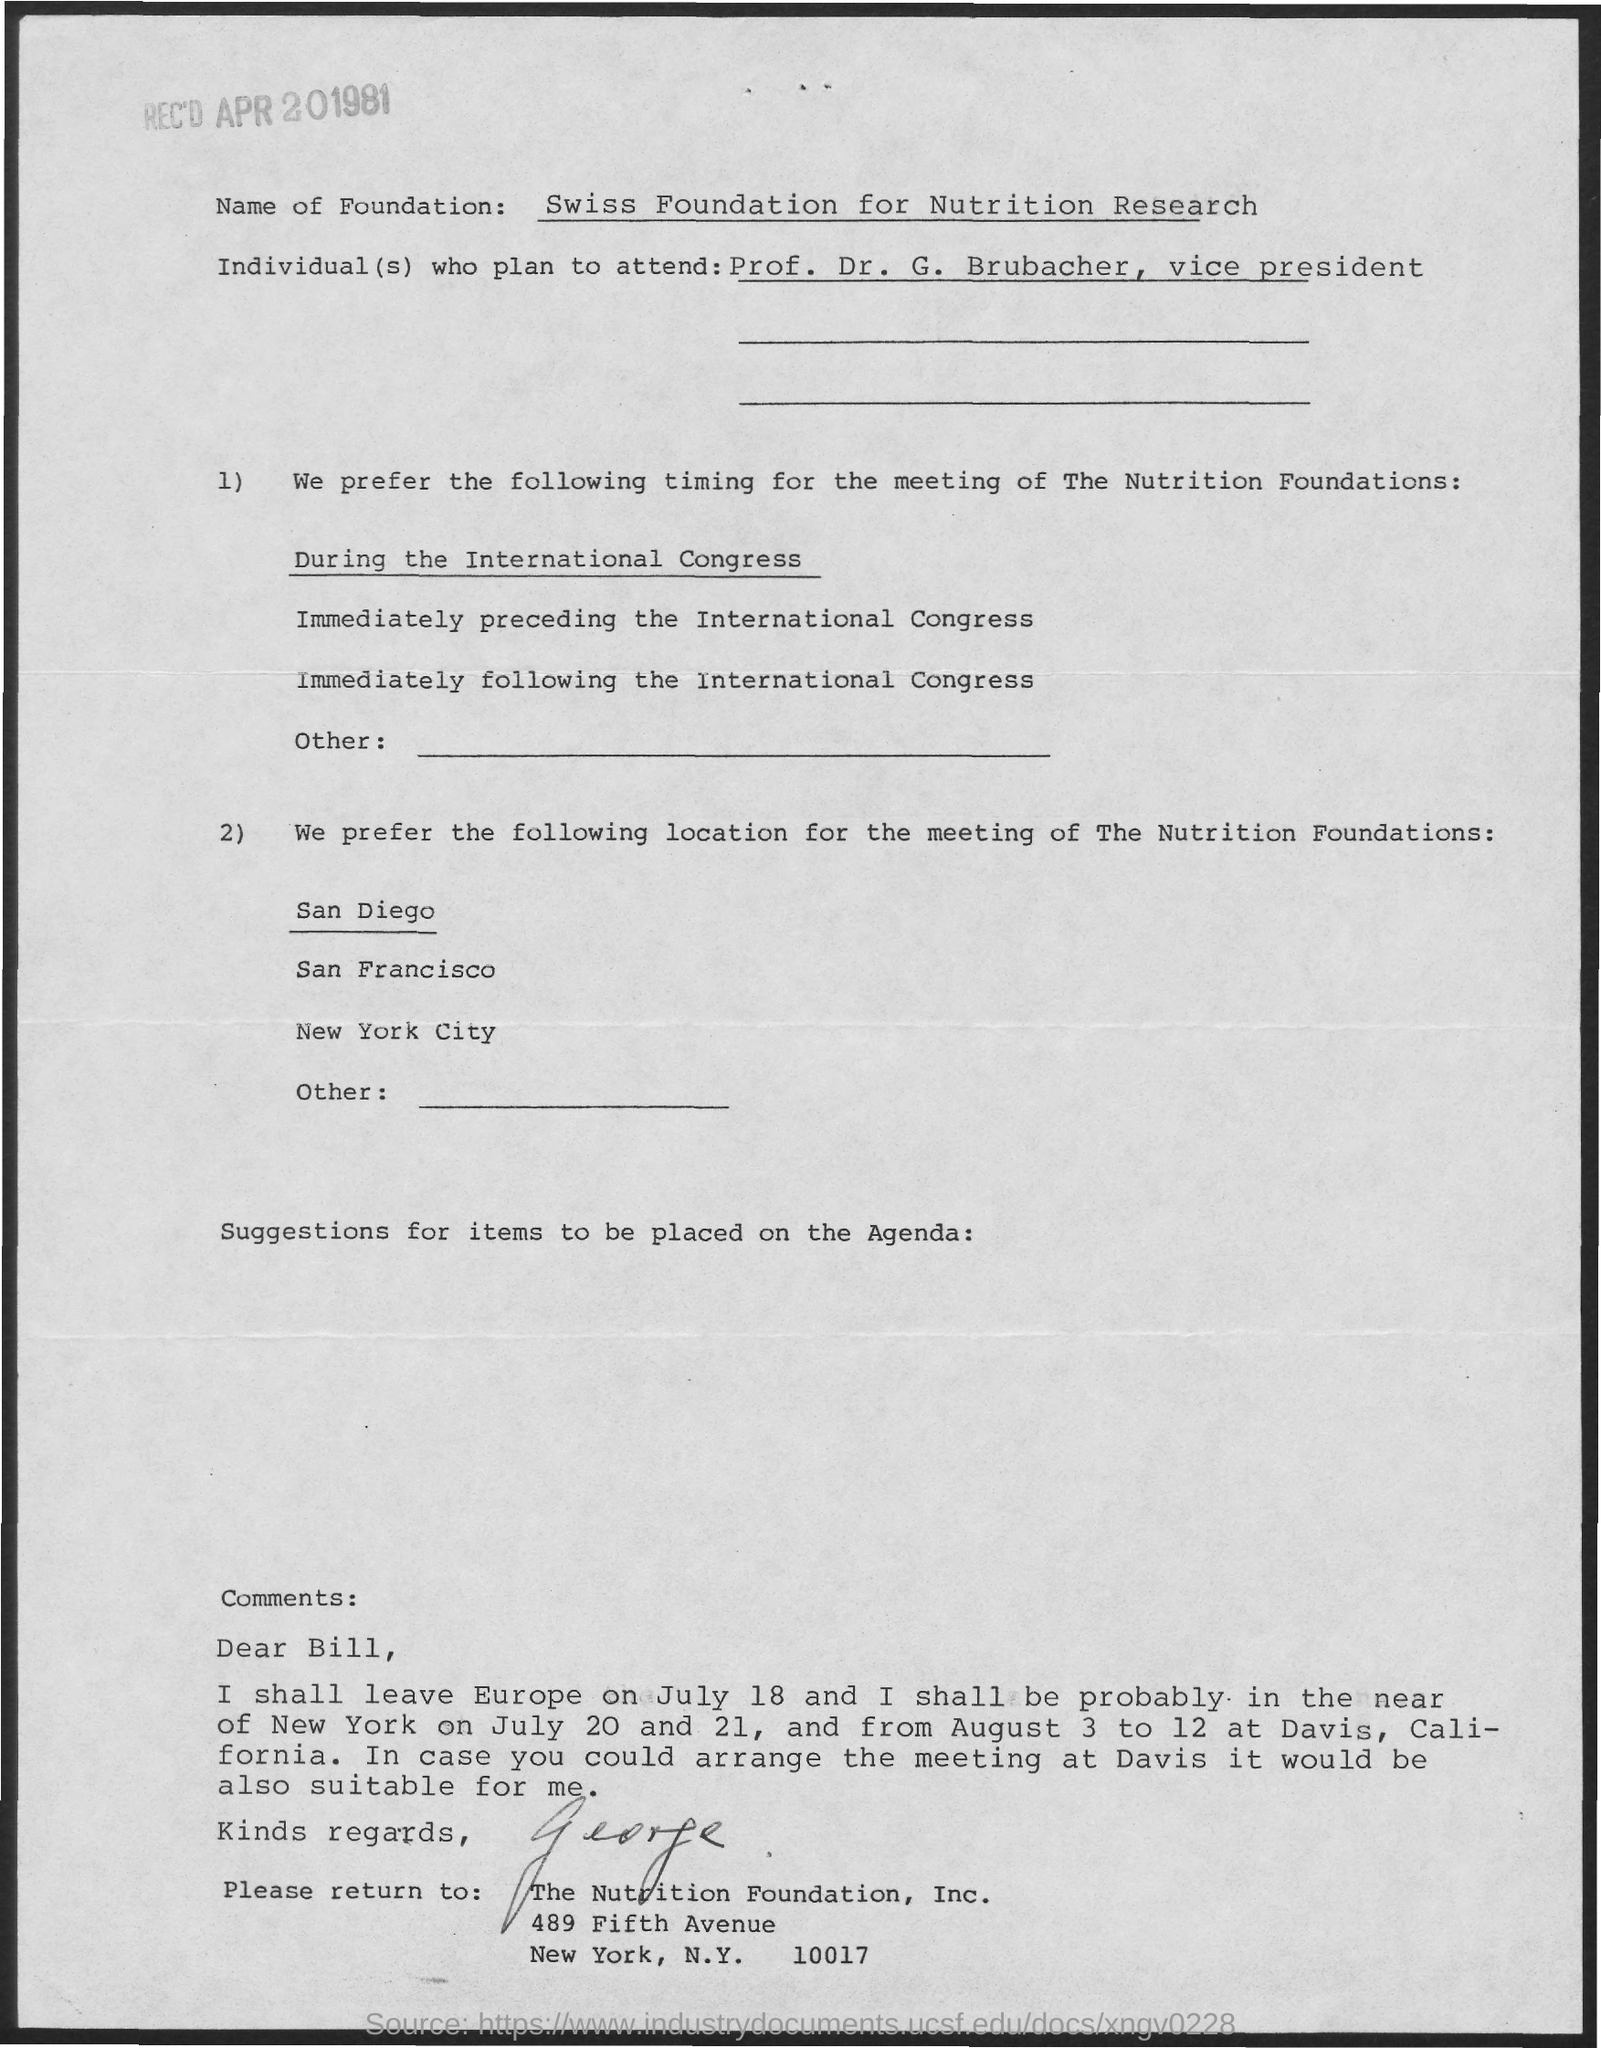What is the name of foundation?
Give a very brief answer. SWISS FOUNDATION FOR NUTRITION RESEARCH. 